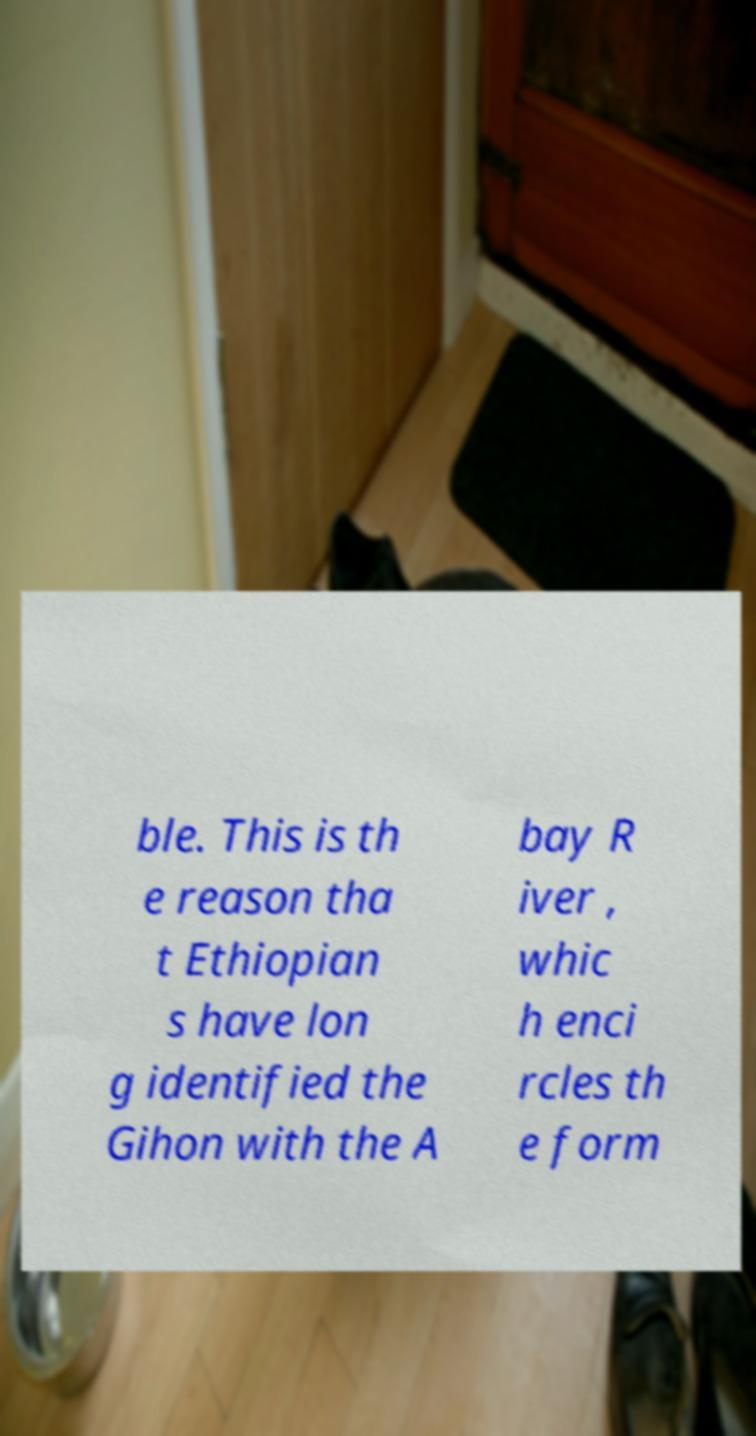What messages or text are displayed in this image? I need them in a readable, typed format. ble. This is th e reason tha t Ethiopian s have lon g identified the Gihon with the A bay R iver , whic h enci rcles th e form 